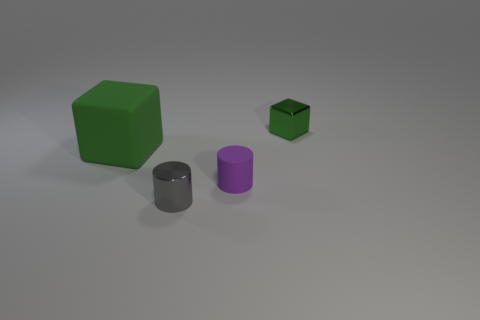Subtract all gray cylinders. How many cylinders are left? 1 Subtract 1 gray cylinders. How many objects are left? 3 Subtract 1 cylinders. How many cylinders are left? 1 Subtract all yellow cubes. Subtract all purple cylinders. How many cubes are left? 2 Subtract all purple balls. How many gray cylinders are left? 1 Subtract all yellow rubber blocks. Subtract all small green metal cubes. How many objects are left? 3 Add 2 large matte blocks. How many large matte blocks are left? 3 Add 1 large shiny balls. How many large shiny balls exist? 1 Add 1 small green shiny blocks. How many objects exist? 5 